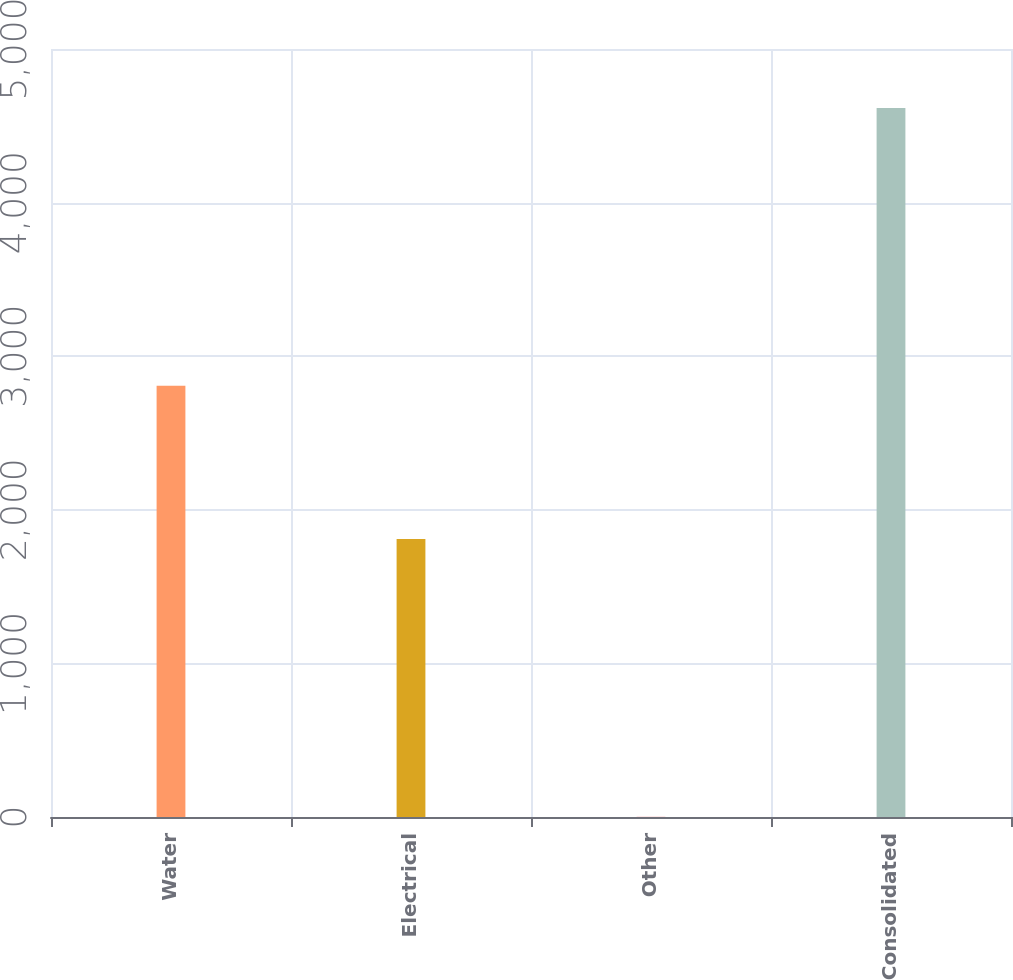<chart> <loc_0><loc_0><loc_500><loc_500><bar_chart><fcel>Water<fcel>Electrical<fcel>Other<fcel>Consolidated<nl><fcel>2808.3<fcel>1809.3<fcel>1.2<fcel>4616.4<nl></chart> 